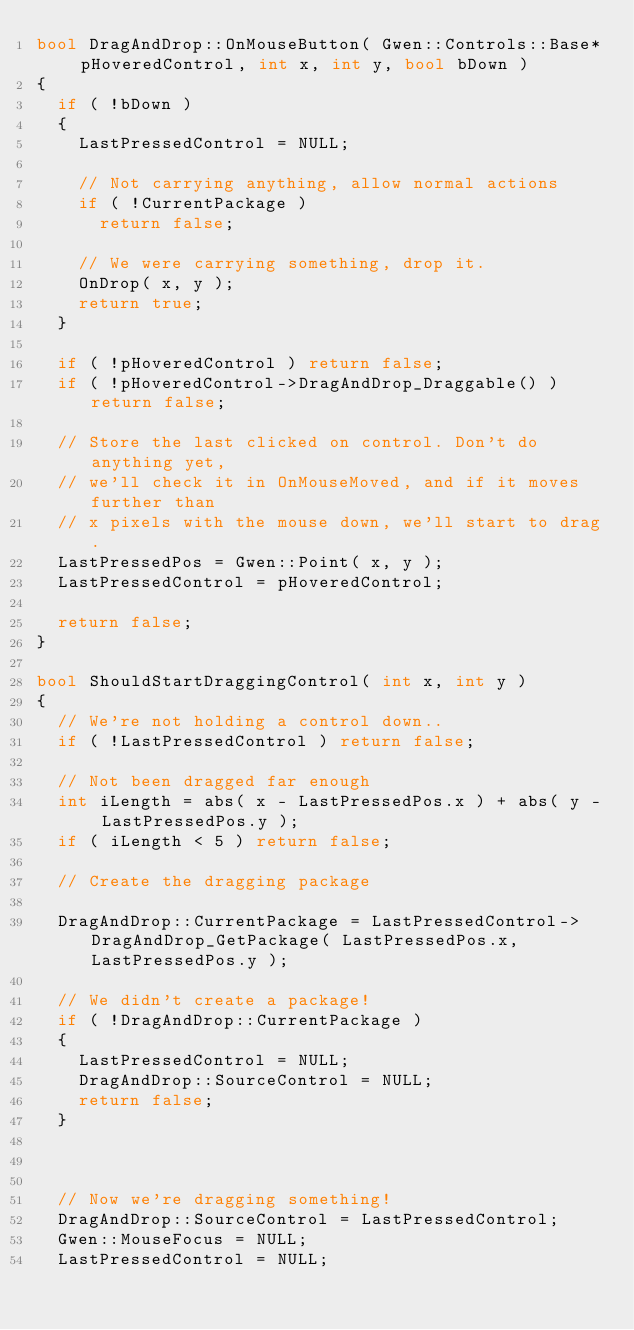Convert code to text. <code><loc_0><loc_0><loc_500><loc_500><_C++_>bool DragAndDrop::OnMouseButton( Gwen::Controls::Base* pHoveredControl, int x, int y, bool bDown )
{
	if ( !bDown )
	{
		LastPressedControl = NULL;

		// Not carrying anything, allow normal actions
		if ( !CurrentPackage ) 
			return false;

		// We were carrying something, drop it.
		OnDrop( x, y );
		return true;
	}

	if ( !pHoveredControl ) return false;
	if ( !pHoveredControl->DragAndDrop_Draggable() ) return false;

	// Store the last clicked on control. Don't do anything yet, 
	// we'll check it in OnMouseMoved, and if it moves further than
	// x pixels with the mouse down, we'll start to drag.
	LastPressedPos = Gwen::Point( x, y );
	LastPressedControl = pHoveredControl;

	return false;
}

bool ShouldStartDraggingControl( int x, int y )
{
	// We're not holding a control down..
	if ( !LastPressedControl ) return false;

	// Not been dragged far enough
	int iLength = abs( x - LastPressedPos.x ) + abs( y - LastPressedPos.y );
	if ( iLength < 5 ) return false;

	// Create the dragging package
	
	DragAndDrop::CurrentPackage = LastPressedControl->DragAndDrop_GetPackage( LastPressedPos.x, LastPressedPos.y );

	// We didn't create a package!
	if ( !DragAndDrop::CurrentPackage )
	{
		LastPressedControl = NULL;
		DragAndDrop::SourceControl = NULL;
		return false;
	}



	// Now we're dragging something!
	DragAndDrop::SourceControl = LastPressedControl;
	Gwen::MouseFocus = NULL;
	LastPressedControl = NULL;</code> 